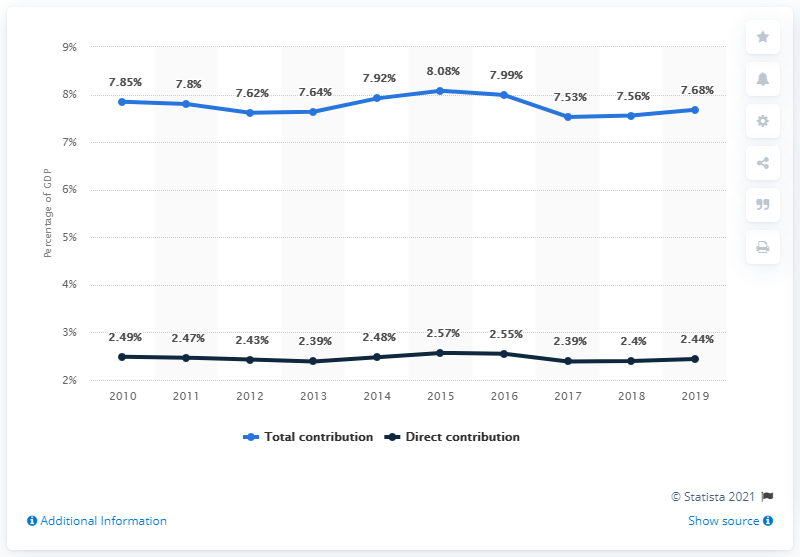Highlight a few significant elements in this photo. The travel and tourism sector contributed an average of 2.49% to Brazil's Gross Domestic Product (GDP) annually over the last 5 years. 